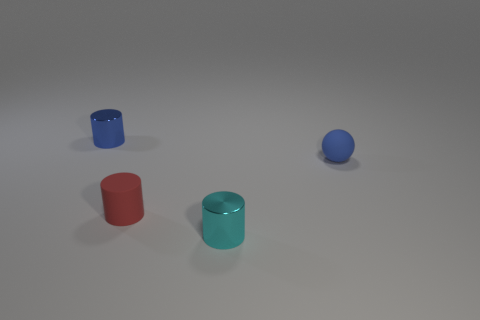There is a tiny blue thing to the right of the tiny cylinder that is behind the tiny blue object right of the blue metal cylinder; what shape is it?
Your answer should be compact. Sphere. Are there more small rubber cylinders that are right of the red rubber cylinder than gray cylinders?
Give a very brief answer. No. Does the small metallic thing behind the cyan cylinder have the same shape as the red rubber thing?
Your answer should be compact. Yes. There is a small object that is left of the tiny red cylinder; what is it made of?
Offer a very short reply. Metal. What number of other tiny objects are the same shape as the tiny red rubber thing?
Offer a very short reply. 2. The blue object on the right side of the tiny blue thing to the left of the cyan object is made of what material?
Your answer should be very brief. Rubber. There is a shiny object that is the same color as the ball; what shape is it?
Ensure brevity in your answer.  Cylinder. Are there any tiny cyan cubes that have the same material as the cyan thing?
Offer a very short reply. No. What shape is the tiny blue matte thing?
Your answer should be very brief. Sphere. What number of big yellow things are there?
Offer a terse response. 0. 